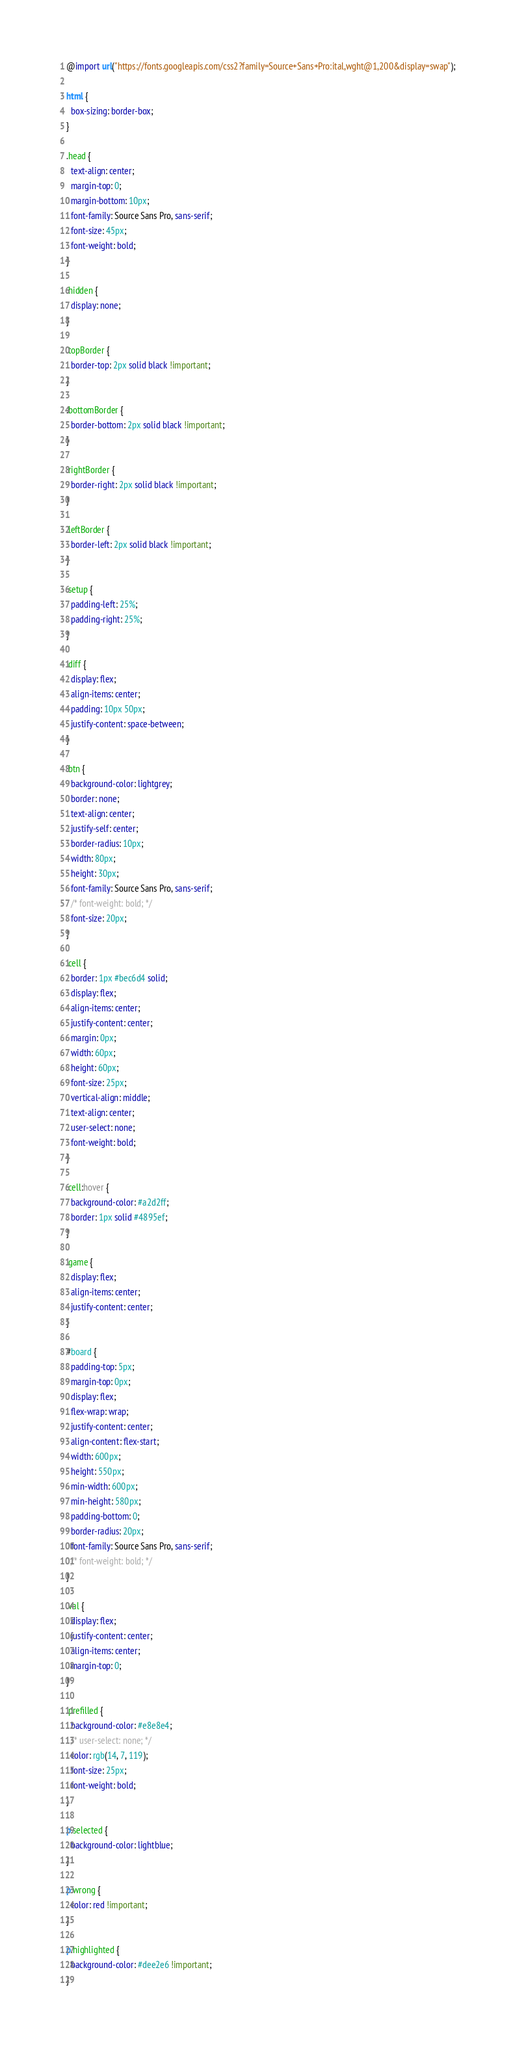Convert code to text. <code><loc_0><loc_0><loc_500><loc_500><_CSS_>@import url("https://fonts.googleapis.com/css2?family=Source+Sans+Pro:ital,wght@1,200&display=swap");

html {
  box-sizing: border-box;
}

.head {
  text-align: center;
  margin-top: 0;
  margin-bottom: 10px;
  font-family: Source Sans Pro, sans-serif;
  font-size: 45px;
  font-weight: bold;
}

.hidden {
  display: none;
}

.topBorder {
  border-top: 2px solid black !important;
}

.bottomBorder {
  border-bottom: 2px solid black !important;
}

.rightBorder {
  border-right: 2px solid black !important;
}

.leftBorder {
  border-left: 2px solid black !important;
}

.setup {
  padding-left: 25%;
  padding-right: 25%;
}

.diff {
  display: flex;
  align-items: center;
  padding: 10px 50px;
  justify-content: space-between;
}

.btn {
  background-color: lightgrey;
  border: none;
  text-align: center;
  justify-self: center;
  border-radius: 10px;
  width: 80px;
  height: 30px;
  font-family: Source Sans Pro, sans-serif;
  /* font-weight: bold; */
  font-size: 20px;
}

.cell {
  border: 1px #bec6d4 solid;
  display: flex;
  align-items: center;
  justify-content: center;
  margin: 0px;
  width: 60px;
  height: 60px;
  font-size: 25px;
  vertical-align: middle;
  text-align: center;
  user-select: none;
  font-weight: bold;
}

.cell:hover {
  background-color: #a2d2ff;
  border: 1px solid #4895ef;
}

.game {
  display: flex;
  align-items: center;
  justify-content: center;
}

#board {
  padding-top: 5px;
  margin-top: 0px;
  display: flex;
  flex-wrap: wrap;
  justify-content: center;
  align-content: flex-start;
  width: 600px;
  height: 550px;
  min-width: 600px;
  min-height: 580px;
  padding-bottom: 0;
  border-radius: 20px;
  font-family: Source Sans Pro, sans-serif;
  /* font-weight: bold; */
}

.val {
  display: flex;
  justify-content: center;
  align-items: center;
  margin-top: 0;
}

.prefilled {
  background-color: #e8e8e4;
  /* user-select: none; */
  color: rgb(14, 7, 119);
  font-size: 25px;
  font-weight: bold;
}

p.selected {
  background-color: lightblue;
}

p.wrong {
  color: red !important;
}

p.highlighted {
  background-color: #dee2e6 !important;
}
</code> 